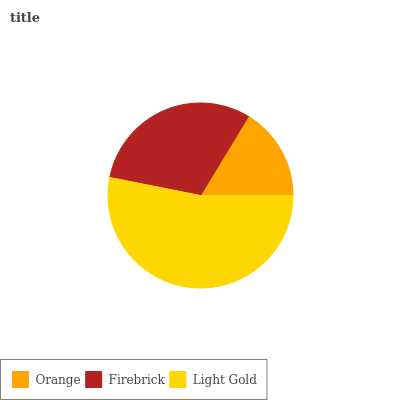Is Orange the minimum?
Answer yes or no. Yes. Is Light Gold the maximum?
Answer yes or no. Yes. Is Firebrick the minimum?
Answer yes or no. No. Is Firebrick the maximum?
Answer yes or no. No. Is Firebrick greater than Orange?
Answer yes or no. Yes. Is Orange less than Firebrick?
Answer yes or no. Yes. Is Orange greater than Firebrick?
Answer yes or no. No. Is Firebrick less than Orange?
Answer yes or no. No. Is Firebrick the high median?
Answer yes or no. Yes. Is Firebrick the low median?
Answer yes or no. Yes. Is Light Gold the high median?
Answer yes or no. No. Is Light Gold the low median?
Answer yes or no. No. 